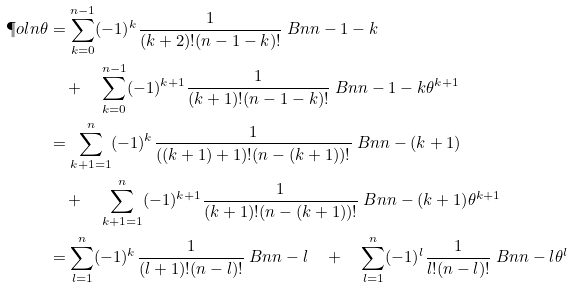<formula> <loc_0><loc_0><loc_500><loc_500>\P o l { n } { \theta } & = \sum _ { k = 0 } ^ { n - 1 } ( - 1 ) ^ { k } \frac { 1 } { ( k + 2 ) ! ( n - 1 - k ) ! } \ B n { n - 1 - k } \\ & \quad + \quad \sum _ { k = 0 } ^ { n - 1 } ( - 1 ) ^ { k + 1 } \frac { 1 } { ( k + 1 ) ! ( n - 1 - k ) ! } \ B n { n - 1 - k } { \theta } ^ { k + 1 } \\ & = \sum _ { k + 1 = 1 } ^ { n } ( - 1 ) ^ { k } \frac { 1 } { ( ( k + 1 ) + 1 ) ! ( n - ( k + 1 ) ) ! } \ B n { n - ( k + 1 ) } \\ & \quad + \quad \sum _ { k + 1 = 1 } ^ { n } ( - 1 ) ^ { k + 1 } \frac { 1 } { ( k + 1 ) ! ( n - ( k + 1 ) ) ! } \ B n { n - ( k + 1 ) } { \theta } ^ { k + 1 } \\ & = \sum _ { l = 1 } ^ { n } ( - 1 ) ^ { k } \frac { 1 } { ( l + 1 ) ! ( n - l ) ! } \ B n { n - l } \quad + \quad \sum _ { l = 1 } ^ { n } ( - 1 ) ^ { l } \frac { 1 } { l ! ( n - l ) ! } \ B n { n - l } { \theta } ^ { l }</formula> 